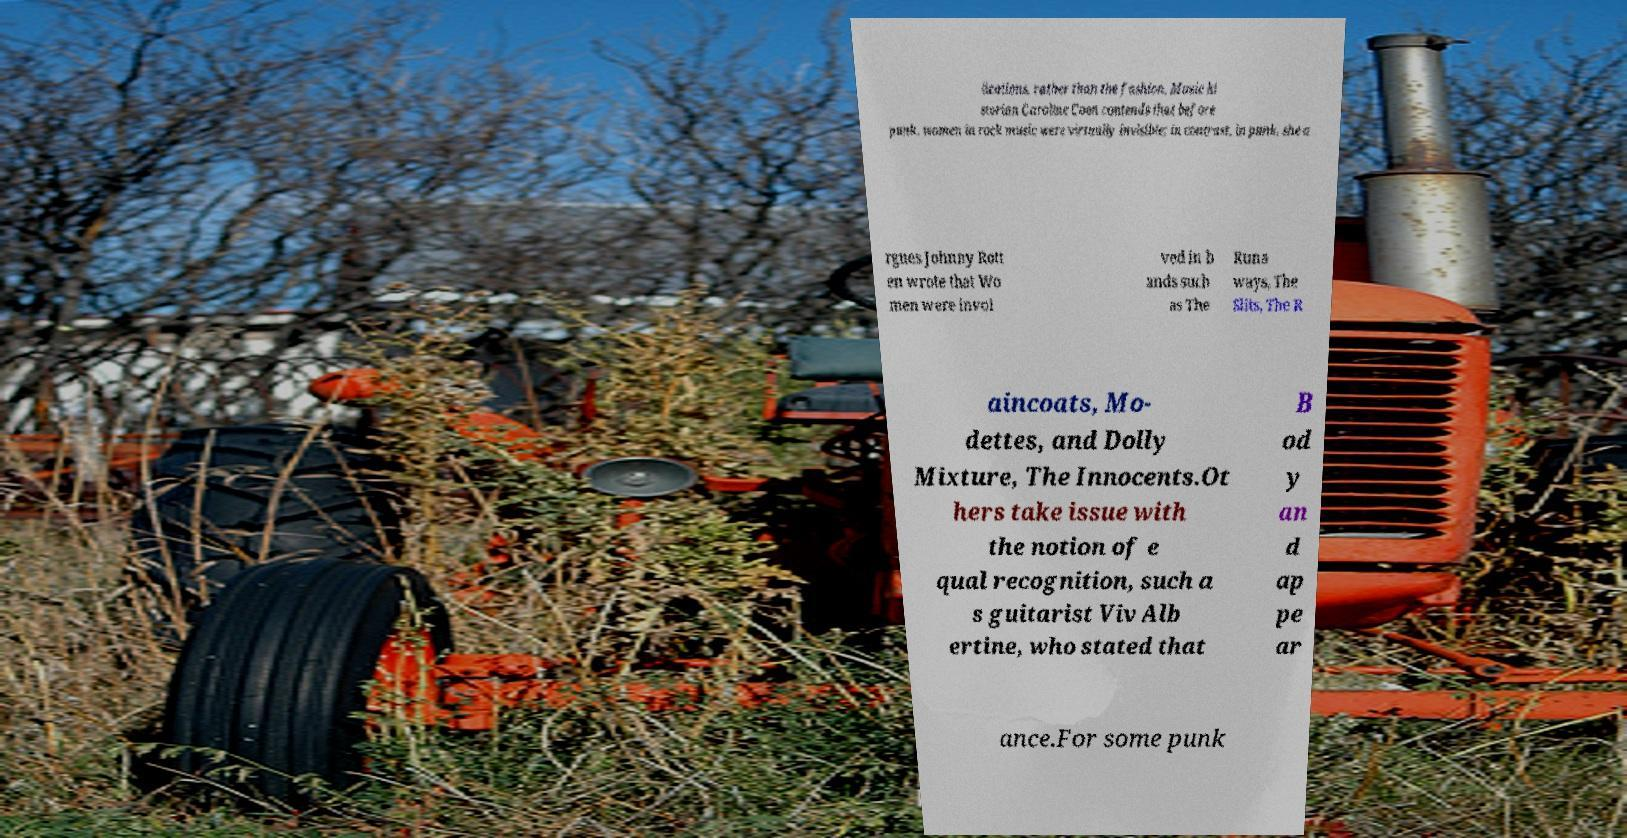What messages or text are displayed in this image? I need them in a readable, typed format. lications, rather than the fashion. Music hi storian Caroline Coon contends that before punk, women in rock music were virtually invisible; in contrast, in punk, she a rgues Johnny Rott en wrote that Wo men were invol ved in b ands such as The Runa ways, The Slits, The R aincoats, Mo- dettes, and Dolly Mixture, The Innocents.Ot hers take issue with the notion of e qual recognition, such a s guitarist Viv Alb ertine, who stated that B od y an d ap pe ar ance.For some punk 